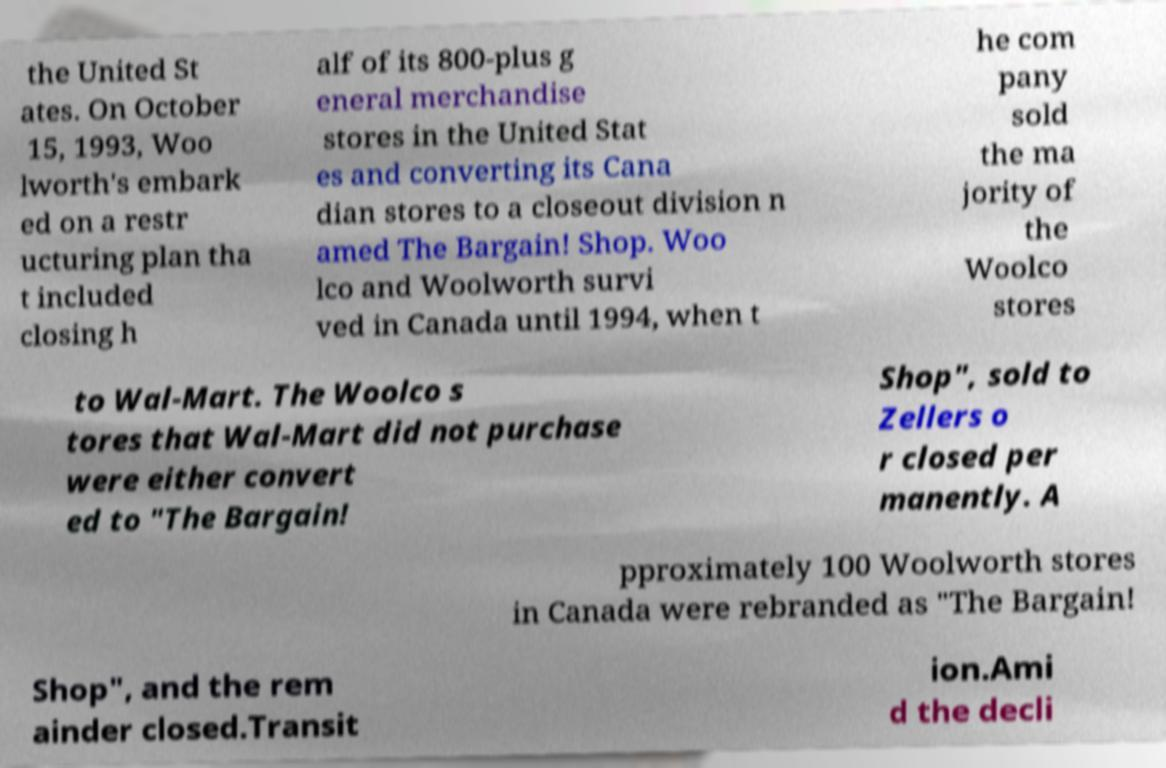There's text embedded in this image that I need extracted. Can you transcribe it verbatim? the United St ates. On October 15, 1993, Woo lworth's embark ed on a restr ucturing plan tha t included closing h alf of its 800-plus g eneral merchandise stores in the United Stat es and converting its Cana dian stores to a closeout division n amed The Bargain! Shop. Woo lco and Woolworth survi ved in Canada until 1994, when t he com pany sold the ma jority of the Woolco stores to Wal-Mart. The Woolco s tores that Wal-Mart did not purchase were either convert ed to "The Bargain! Shop", sold to Zellers o r closed per manently. A pproximately 100 Woolworth stores in Canada were rebranded as "The Bargain! Shop", and the rem ainder closed.Transit ion.Ami d the decli 